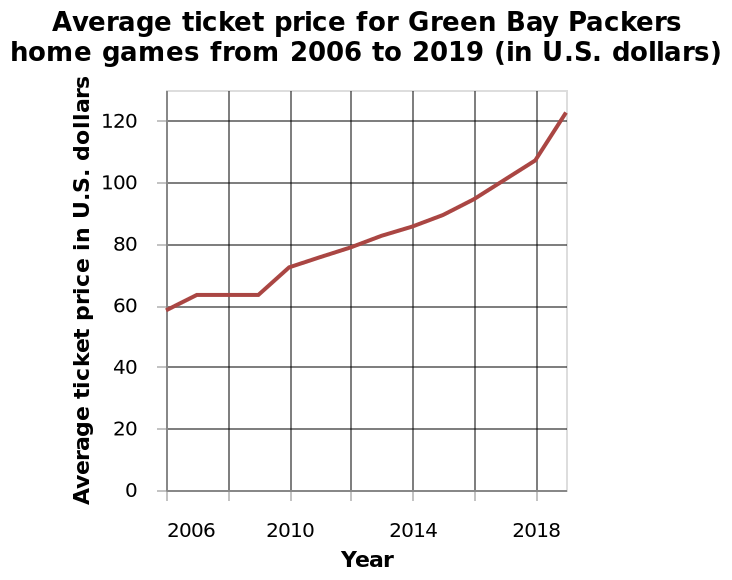<image>
What can be said about the trend of the ticket price based on the graph? Based on the graph, the price of the ticket shows an overall increasing trend, although the increase year to year is not consistent. How much has the price increased? The price has doubled over the 13 years shown on the graph. What does the y-axis measure on the line graph?  The y-axis measures the average ticket price in U.S. dollars. Which currency is used to measure the average ticket price?  The average ticket price is measured in U.S. dollars. 